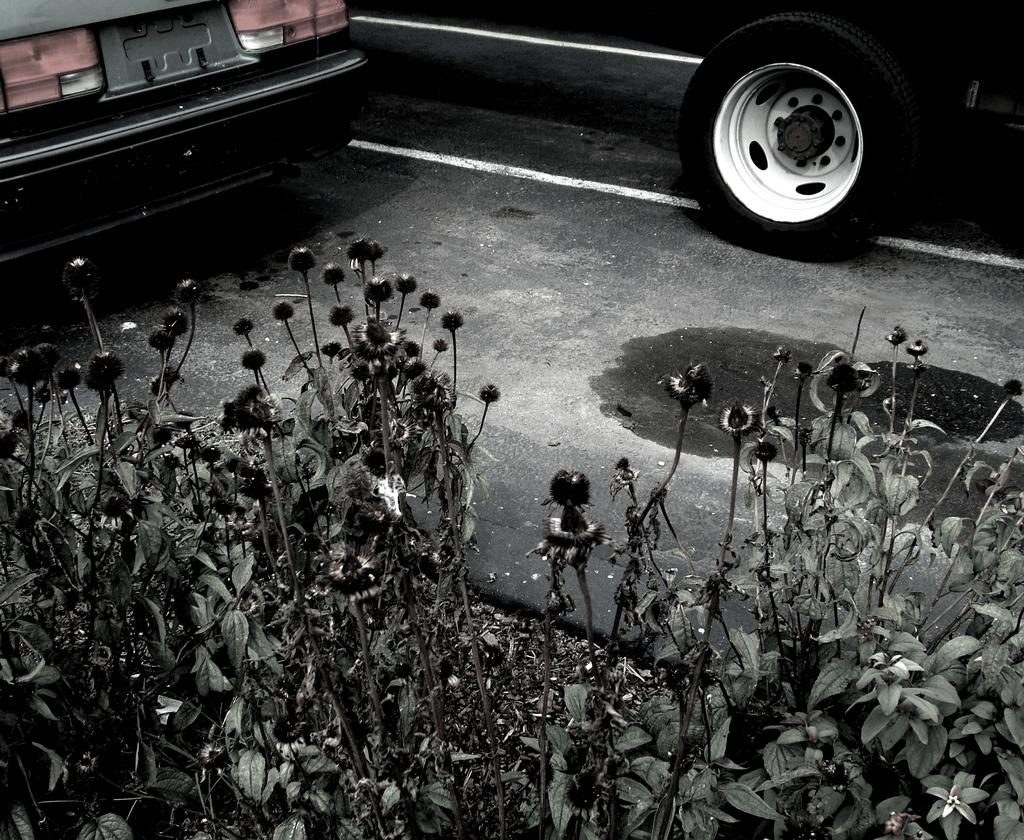What is in the foreground of the image? There are plants and vehicles on the road in the foreground of the image. What time of day is the image taken? The image is taken during nighttime. Where is the image taken? The image is taken on a road. What type of pear can be seen on the road in the image? There is no pear present in the image; the foreground features plants and vehicles on a road. How do the plants and vehicles talk to each other in the image? Plants and vehicles do not have the ability to talk, so this interaction cannot be observed in the image. 